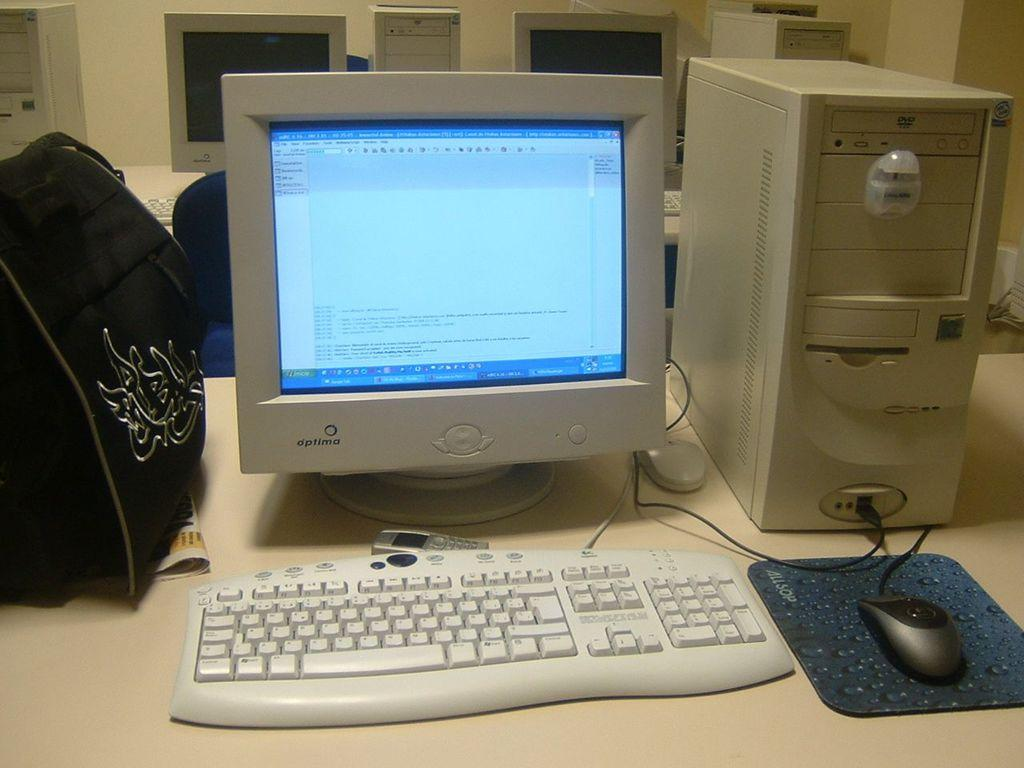<image>
Offer a succinct explanation of the picture presented. a computer with the label 'optima' on the bottom left of it 